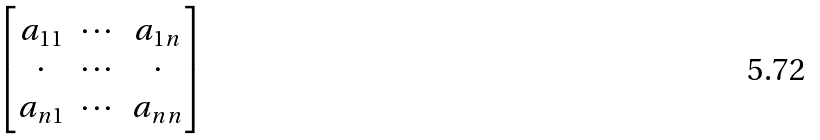Convert formula to latex. <formula><loc_0><loc_0><loc_500><loc_500>\begin{bmatrix} a _ { 1 1 } & \cdots & a _ { 1 n } \\ \cdot & \cdots & \cdot \\ a _ { n 1 } & \cdots & a _ { n n } \\ \end{bmatrix}</formula> 